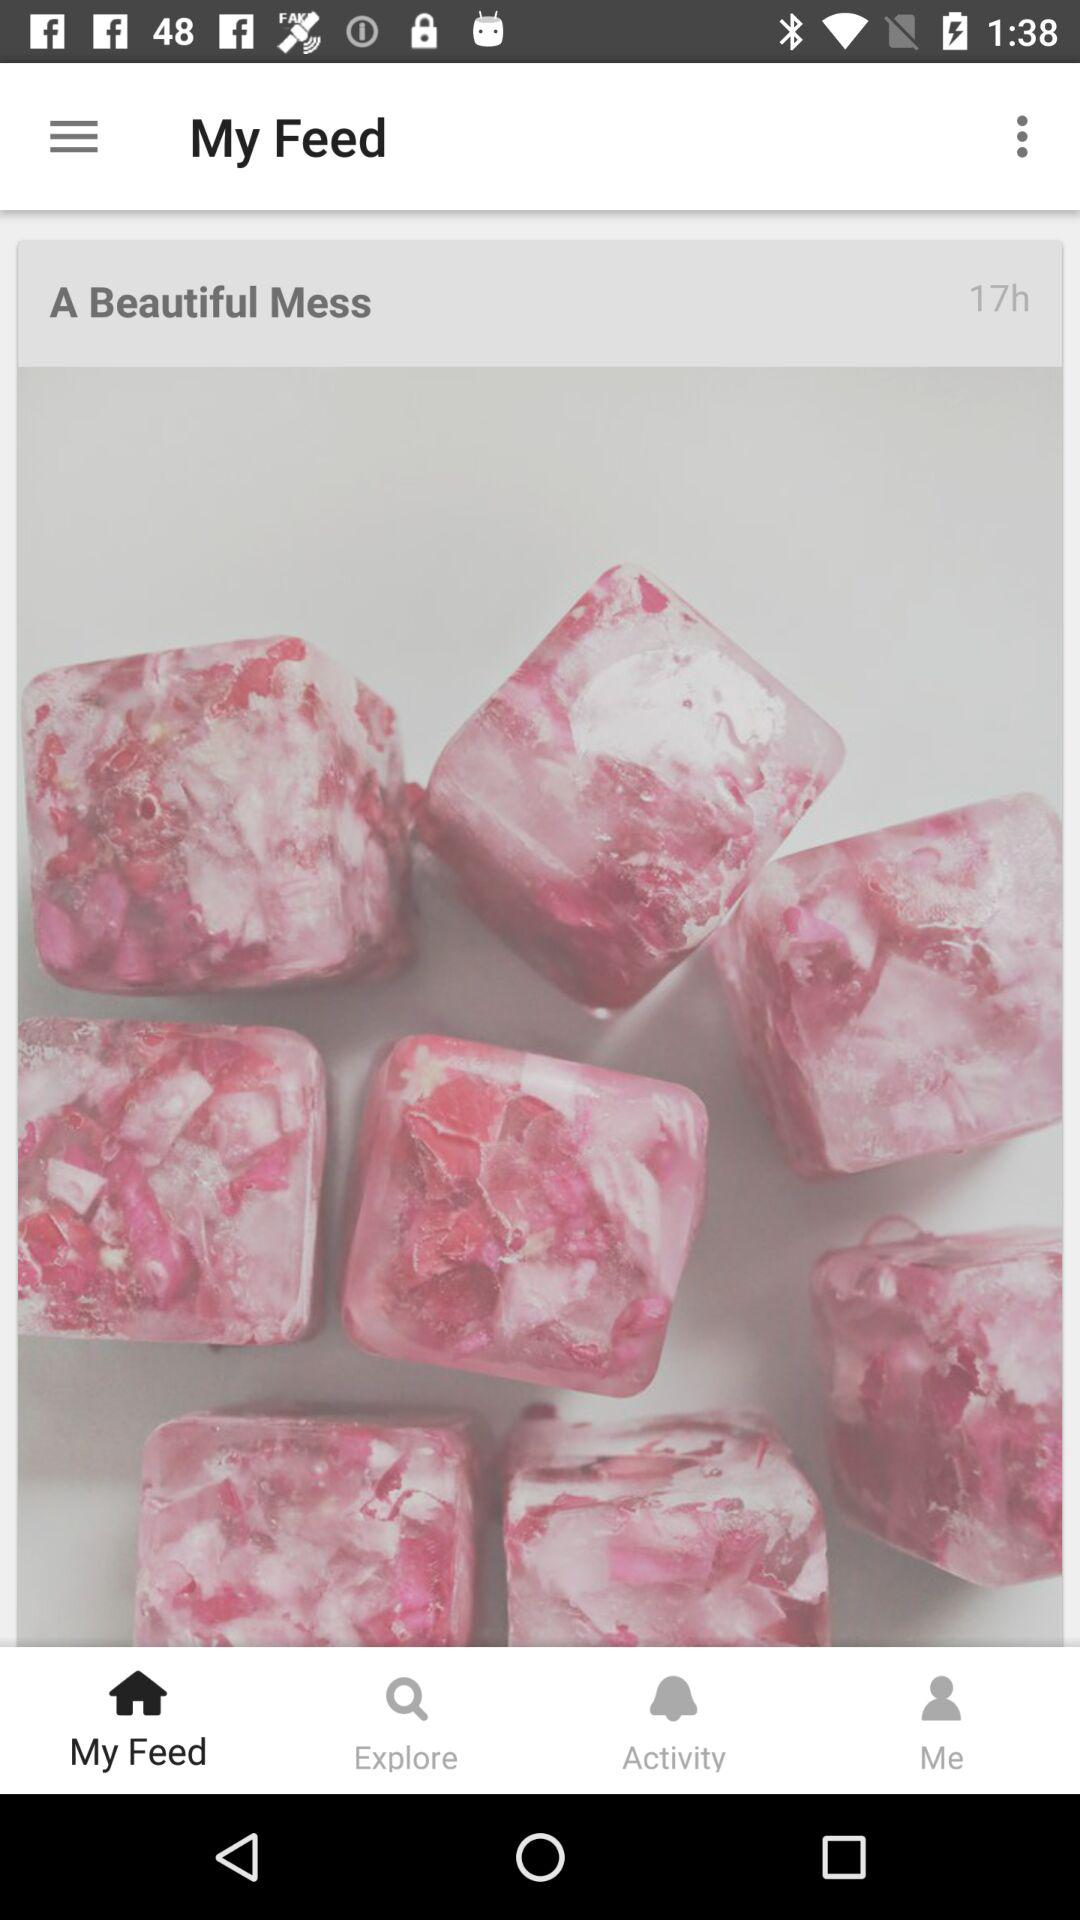How many hours ago was the post created?
Answer the question using a single word or phrase. 17 